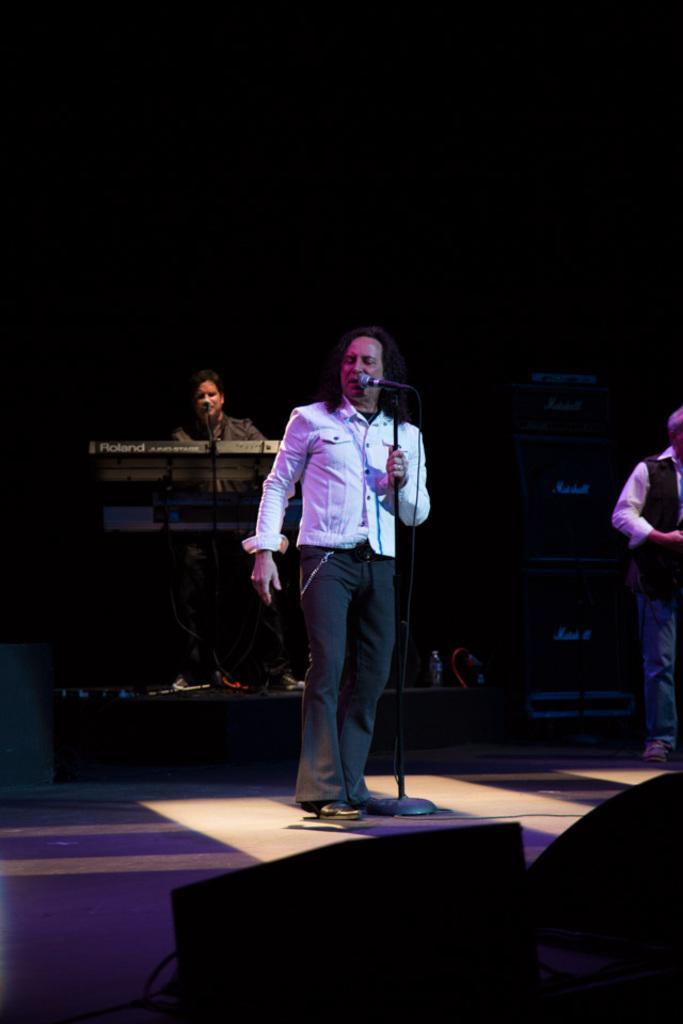How would you summarize this image in a sentence or two? In this image, I can see a man standing. This is the mic attached to the mike stand. I can see a person sitting and playing piano. On the right side of the image, I can see a person standing. This looks like an object, which is black in color. 